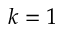Convert formula to latex. <formula><loc_0><loc_0><loc_500><loc_500>k = 1</formula> 